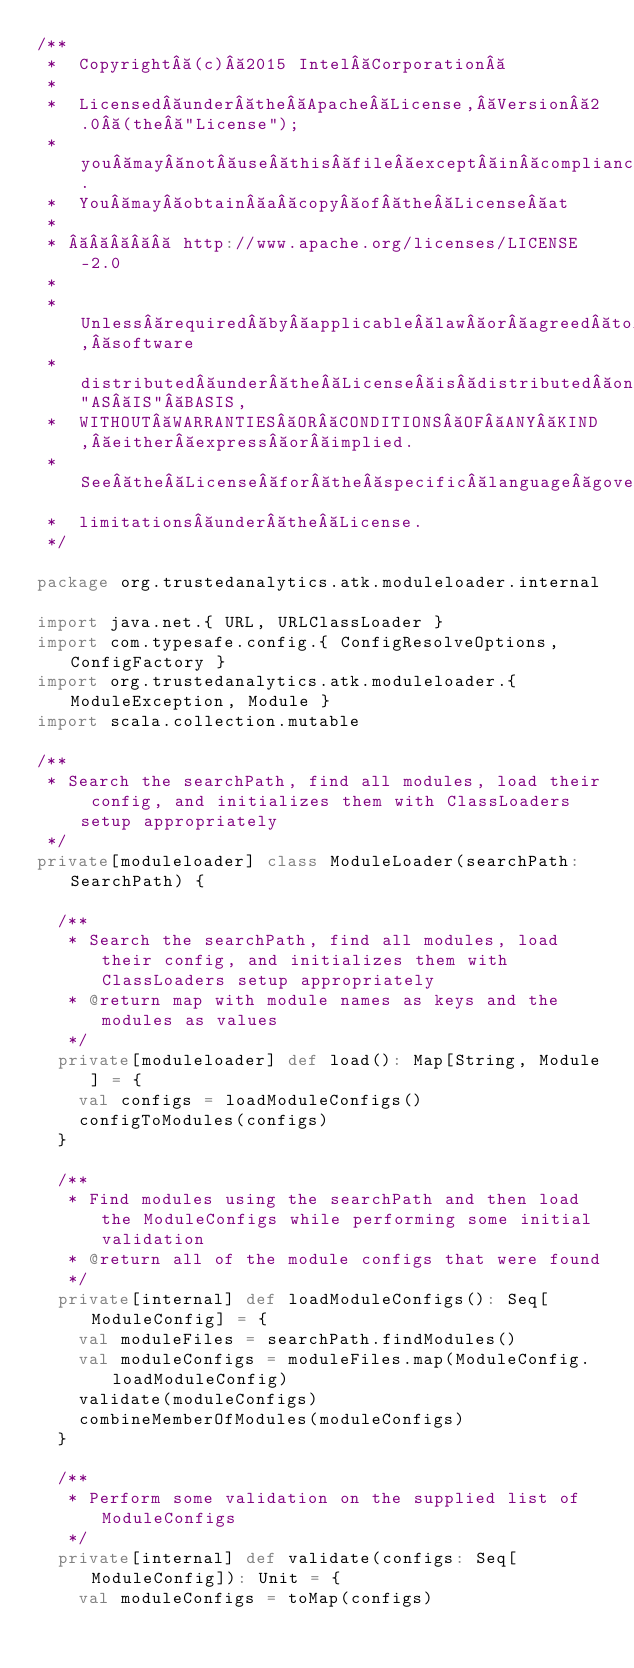<code> <loc_0><loc_0><loc_500><loc_500><_Scala_>/**
 *  Copyright (c) 2015 Intel Corporation 
 *
 *  Licensed under the Apache License, Version 2.0 (the "License");
 *  you may not use this file except in compliance with the License.
 *  You may obtain a copy of the License at
 *
 *       http://www.apache.org/licenses/LICENSE-2.0
 *
 *  Unless required by applicable law or agreed to in writing, software
 *  distributed under the License is distributed on an "AS IS" BASIS,
 *  WITHOUT WARRANTIES OR CONDITIONS OF ANY KIND, either express or implied.
 *  See the License for the specific language governing permissions and
 *  limitations under the License.
 */

package org.trustedanalytics.atk.moduleloader.internal

import java.net.{ URL, URLClassLoader }
import com.typesafe.config.{ ConfigResolveOptions, ConfigFactory }
import org.trustedanalytics.atk.moduleloader.{ ModuleException, Module }
import scala.collection.mutable

/**
 * Search the searchPath, find all modules, load their config, and initializes them with ClassLoaders setup appropriately
 */
private[moduleloader] class ModuleLoader(searchPath: SearchPath) {

  /**
   * Search the searchPath, find all modules, load their config, and initializes them with ClassLoaders setup appropriately
   * @return map with module names as keys and the modules as values
   */
  private[moduleloader] def load(): Map[String, Module] = {
    val configs = loadModuleConfigs()
    configToModules(configs)
  }

  /**
   * Find modules using the searchPath and then load the ModuleConfigs while performing some initial validation
   * @return all of the module configs that were found
   */
  private[internal] def loadModuleConfigs(): Seq[ModuleConfig] = {
    val moduleFiles = searchPath.findModules()
    val moduleConfigs = moduleFiles.map(ModuleConfig.loadModuleConfig)
    validate(moduleConfigs)
    combineMemberOfModules(moduleConfigs)
  }

  /**
   * Perform some validation on the supplied list of ModuleConfigs
   */
  private[internal] def validate(configs: Seq[ModuleConfig]): Unit = {
    val moduleConfigs = toMap(configs)</code> 